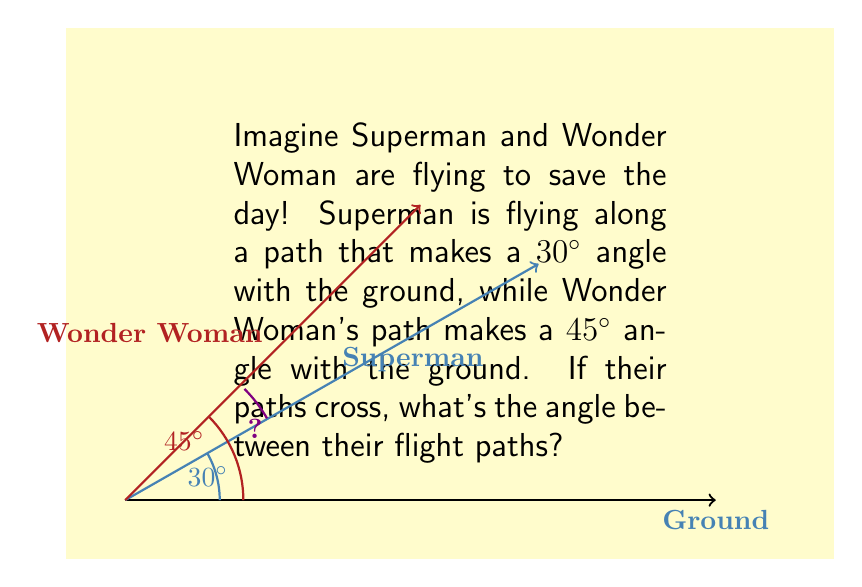Provide a solution to this math problem. Let's break this down step-by-step:

1) In Non-Euclidean geometry, we often use the concept of spherical geometry to solve problems involving flight paths, as they occur on the curved surface of the Earth.

2) However, for small distances, we can approximate the Earth's surface as a flat plane, which allows us to use simpler Euclidean geometry.

3) In this case, we can use the concept of complementary angles. The angle between each hero's flight path and the vertical line (perpendicular to the ground) is the complement of the angle given.

   For Superman: $90° - 30° = 60°$
   For Wonder Woman: $90° - 45° = 45°$

4) The angle between their flight paths is the difference between these complementary angles:

   $|60° - 45°| = 15°$

5) We use the absolute value because we're interested in the smallest angle between the paths, regardless of which hero is flying "higher".

So, the angle between Superman and Wonder Woman's flight paths is $15°$.
Answer: $15°$ 